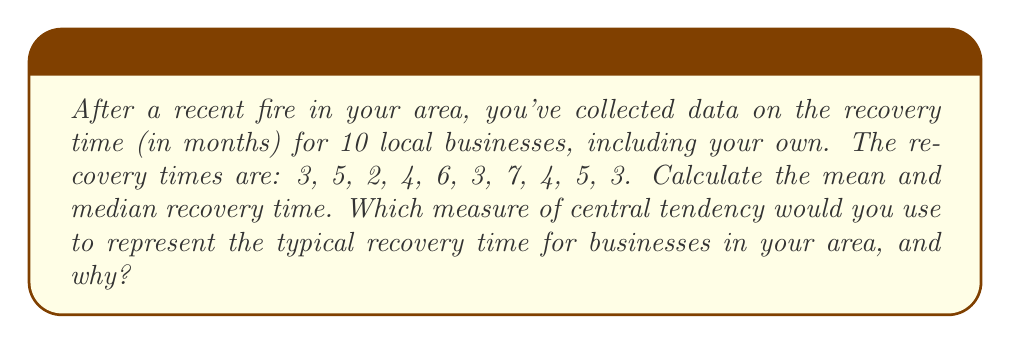Can you answer this question? To solve this problem, we'll calculate both the mean and median, then discuss which is more appropriate.

Step 1: Calculate the mean
The mean is the sum of all values divided by the number of values.

$$ \text{Mean} = \frac{\sum_{i=1}^{n} x_i}{n} $$

Where $x_i$ are the individual values and $n$ is the number of values.

$$ \text{Mean} = \frac{3 + 5 + 2 + 4 + 6 + 3 + 7 + 4 + 5 + 3}{10} = \frac{42}{10} = 4.2 \text{ months} $$

Step 2: Calculate the median
First, arrange the data in ascending order:
2, 3, 3, 3, 4, 4, 5, 5, 6, 7

With 10 values, the median is the average of the 5th and 6th values:

$$ \text{Median} = \frac{4 + 4}{2} = 4 \text{ months} $$

Step 3: Choose the appropriate measure
The median (4 months) is slightly lower than the mean (4.2 months). The median is generally more robust to outliers and gives a better representation of the typical value in skewed distributions. In this case, there's a slight positive skew due to the presence of a few longer recovery times (6 and 7 months).

As a local business owner, you might prefer to use the median to represent the typical recovery time. It's less affected by the few businesses that took longer to recover and might give a more realistic expectation for most businesses in the area.
Answer: Median: 4 months. It's less affected by outliers and better represents the typical recovery time in this slightly skewed distribution. 